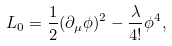Convert formula to latex. <formula><loc_0><loc_0><loc_500><loc_500>L _ { 0 } = \frac { 1 } { 2 } ( \partial _ { \mu } \phi ) ^ { 2 } - \frac { \lambda } { 4 ! } \phi ^ { 4 } ,</formula> 